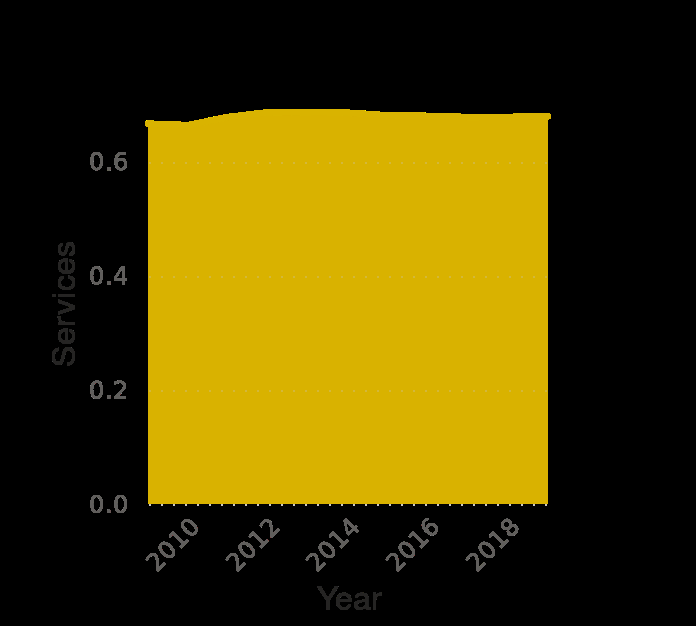<image>
Has there been any significant change in the distribution of gross domestic products over the past 8 years?  No, there has not been any significant change in the distribution of gross domestic products over the past 8 years. What is being measured on the y-axis? The y-axis measures the contribution of services to the gross domestic product (GDP) in Spain. Are there any specific trends or patterns shown in the area plot? Without seeing the actual plot, it is not possible to determine specific trends or patterns. Offer a thorough analysis of the image. In the past 8 years distribution of gross domestic products slightly increased and it keeps it`s level. 